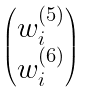<formula> <loc_0><loc_0><loc_500><loc_500>\begin{pmatrix} w ^ { ( 5 ) } _ { i } \\ w ^ { ( 6 ) } _ { i } \end{pmatrix}</formula> 